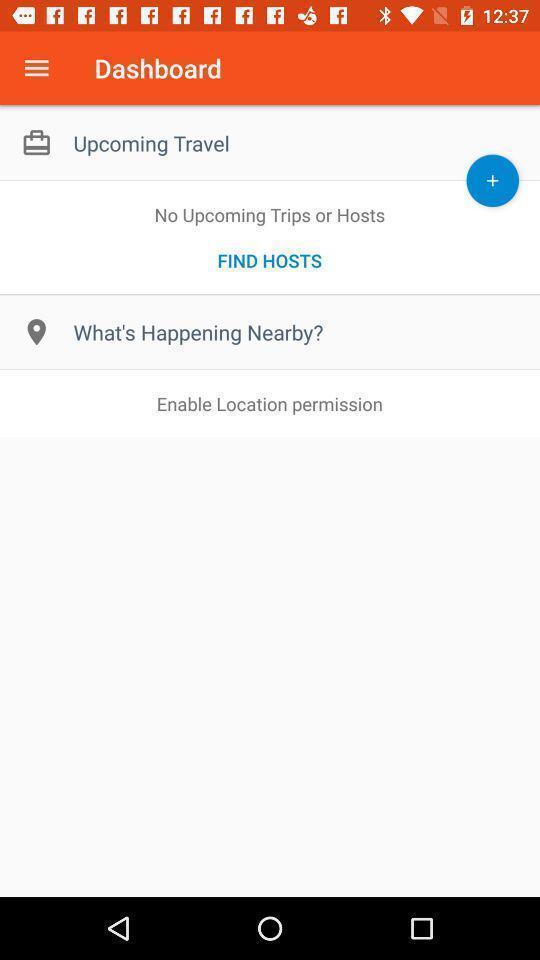Explain what's happening in this screen capture. Screen displaying dashboard of a travel app. 